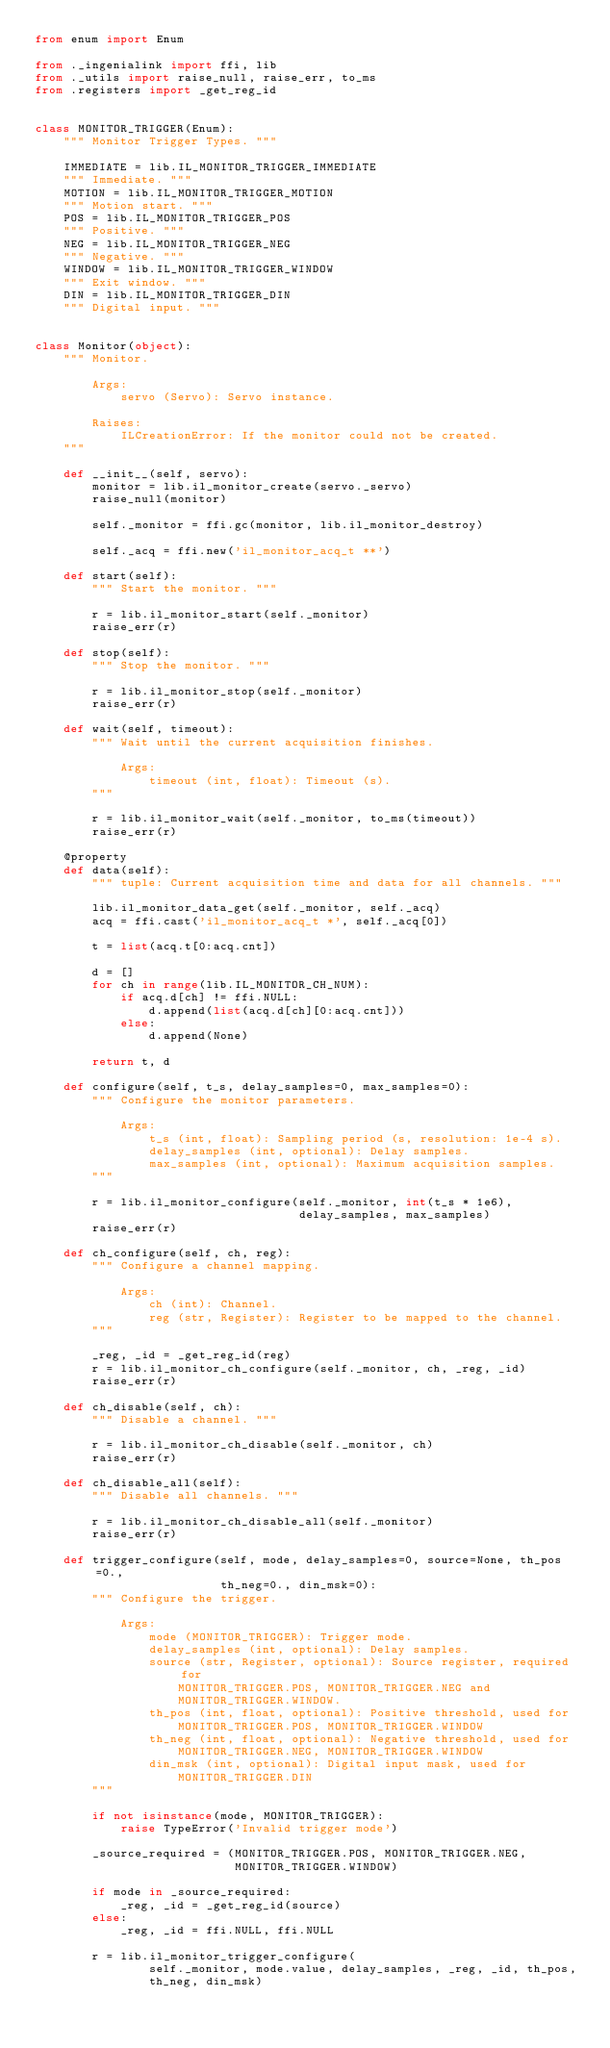<code> <loc_0><loc_0><loc_500><loc_500><_Python_>from enum import Enum

from ._ingenialink import ffi, lib
from ._utils import raise_null, raise_err, to_ms
from .registers import _get_reg_id


class MONITOR_TRIGGER(Enum):
    """ Monitor Trigger Types. """

    IMMEDIATE = lib.IL_MONITOR_TRIGGER_IMMEDIATE
    """ Immediate. """
    MOTION = lib.IL_MONITOR_TRIGGER_MOTION
    """ Motion start. """
    POS = lib.IL_MONITOR_TRIGGER_POS
    """ Positive. """
    NEG = lib.IL_MONITOR_TRIGGER_NEG
    """ Negative. """
    WINDOW = lib.IL_MONITOR_TRIGGER_WINDOW
    """ Exit window. """
    DIN = lib.IL_MONITOR_TRIGGER_DIN
    """ Digital input. """


class Monitor(object):
    """ Monitor.

        Args:
            servo (Servo): Servo instance.

        Raises:
            ILCreationError: If the monitor could not be created.
    """

    def __init__(self, servo):
        monitor = lib.il_monitor_create(servo._servo)
        raise_null(monitor)

        self._monitor = ffi.gc(monitor, lib.il_monitor_destroy)

        self._acq = ffi.new('il_monitor_acq_t **')

    def start(self):
        """ Start the monitor. """

        r = lib.il_monitor_start(self._monitor)
        raise_err(r)

    def stop(self):
        """ Stop the monitor. """

        r = lib.il_monitor_stop(self._monitor)
        raise_err(r)

    def wait(self, timeout):
        """ Wait until the current acquisition finishes.

            Args:
                timeout (int, float): Timeout (s).
        """

        r = lib.il_monitor_wait(self._monitor, to_ms(timeout))
        raise_err(r)

    @property
    def data(self):
        """ tuple: Current acquisition time and data for all channels. """

        lib.il_monitor_data_get(self._monitor, self._acq)
        acq = ffi.cast('il_monitor_acq_t *', self._acq[0])

        t = list(acq.t[0:acq.cnt])

        d = []
        for ch in range(lib.IL_MONITOR_CH_NUM):
            if acq.d[ch] != ffi.NULL:
                d.append(list(acq.d[ch][0:acq.cnt]))
            else:
                d.append(None)

        return t, d

    def configure(self, t_s, delay_samples=0, max_samples=0):
        """ Configure the monitor parameters.

            Args:
                t_s (int, float): Sampling period (s, resolution: 1e-4 s).
                delay_samples (int, optional): Delay samples.
                max_samples (int, optional): Maximum acquisition samples.
        """

        r = lib.il_monitor_configure(self._monitor, int(t_s * 1e6),
                                     delay_samples, max_samples)
        raise_err(r)

    def ch_configure(self, ch, reg):
        """ Configure a channel mapping.

            Args:
                ch (int): Channel.
                reg (str, Register): Register to be mapped to the channel.
        """

        _reg, _id = _get_reg_id(reg)
        r = lib.il_monitor_ch_configure(self._monitor, ch, _reg, _id)
        raise_err(r)

    def ch_disable(self, ch):
        """ Disable a channel. """

        r = lib.il_monitor_ch_disable(self._monitor, ch)
        raise_err(r)

    def ch_disable_all(self):
        """ Disable all channels. """

        r = lib.il_monitor_ch_disable_all(self._monitor)
        raise_err(r)

    def trigger_configure(self, mode, delay_samples=0, source=None, th_pos=0.,
                          th_neg=0., din_msk=0):
        """ Configure the trigger.

            Args:
                mode (MONITOR_TRIGGER): Trigger mode.
                delay_samples (int, optional): Delay samples.
                source (str, Register, optional): Source register, required for
                    MONITOR_TRIGGER.POS, MONITOR_TRIGGER.NEG and
                    MONITOR_TRIGGER.WINDOW.
                th_pos (int, float, optional): Positive threshold, used for
                    MONITOR_TRIGGER.POS, MONITOR_TRIGGER.WINDOW
                th_neg (int, float, optional): Negative threshold, used for
                    MONITOR_TRIGGER.NEG, MONITOR_TRIGGER.WINDOW
                din_msk (int, optional): Digital input mask, used for
                    MONITOR_TRIGGER.DIN
        """

        if not isinstance(mode, MONITOR_TRIGGER):
            raise TypeError('Invalid trigger mode')

        _source_required = (MONITOR_TRIGGER.POS, MONITOR_TRIGGER.NEG,
                            MONITOR_TRIGGER.WINDOW)

        if mode in _source_required:
            _reg, _id = _get_reg_id(source)
        else:
            _reg, _id = ffi.NULL, ffi.NULL

        r = lib.il_monitor_trigger_configure(
                self._monitor, mode.value, delay_samples, _reg, _id, th_pos,
                th_neg, din_msk)</code> 